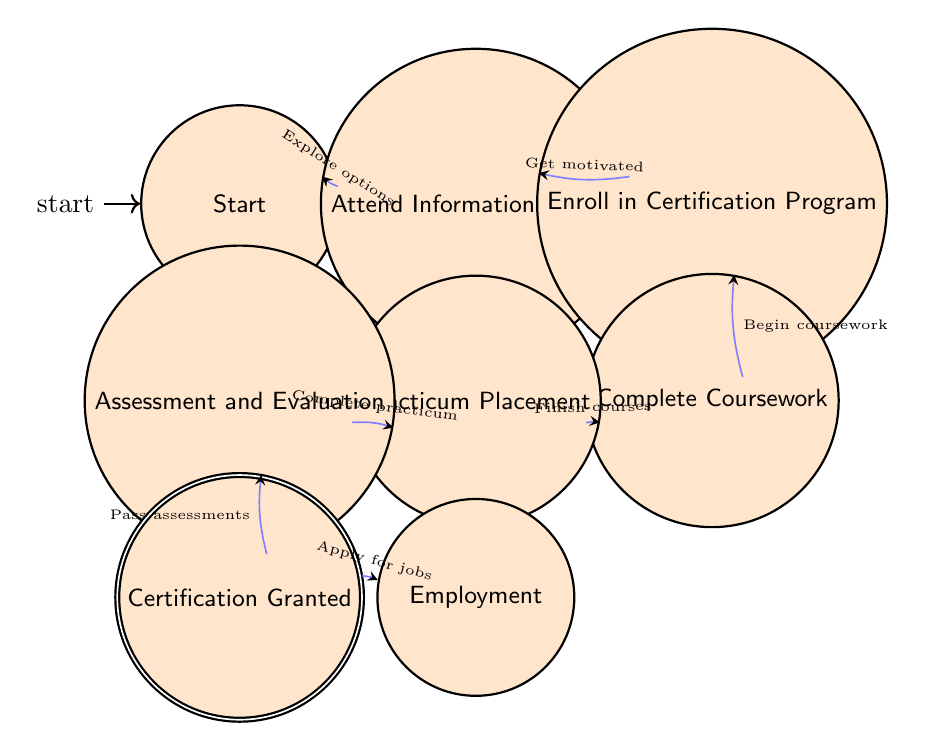What is the starting state in the certification journey? The diagram indicates that the starting state is "Start," where the teacher begins their journey.
Answer: Start How many nodes are there in the diagram? By counting the distinct states listed in the diagram, there are a total of eight nodes or states present.
Answer: Eight What is the final state after certification? The diagram shows that after "Certification Granted," the next state is "Employment," which is the final state in the journey.
Answer: Employment What triggers the transition from "Assessment and Evaluation" to "Certification Granted"? The transition is triggered when the teacher successfully passes assessments and evaluations, as indicated in the diagram.
Answer: Pass assessments Which state follows "Enroll in Certification Program"? According to the transitions in the diagram, "Complete Coursework" directly follows "Enroll in Certification Program."
Answer: Complete Coursework What type of placement does the teacher undertake before certification? The teacher undertakes a "Practicum Placement" for hands-on experience before proceeding to assessment.
Answer: Practicum Placement What does the teacher do after being granted certification? The teacher starts the job application process for employment once certification is granted, as shown in the flow.
Answer: Apply for jobs What state does the teacher reach after they finish their courses? After completing their coursework, the teacher moves to the "Practicum Placement" state, as indicated in the transition.
Answer: Practicum Placement Which two states are connected by the "Get motivated" trigger? The states "Attend Information Session" and "Enroll in Certification Program" are connected via the trigger "Get motivated."
Answer: Attend Information Session, Enroll in Certification Program 